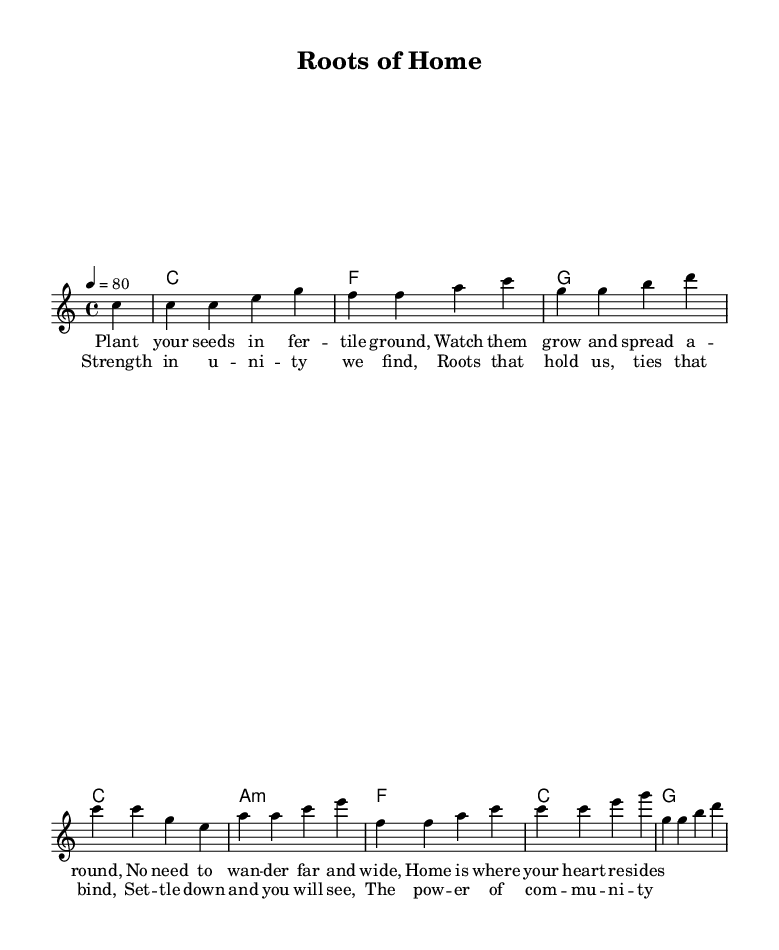What is the key signature of this music? The key signature is C major, which has no sharps or flats.
Answer: C major What is the time signature of this music piece? The time signature is indicated at the beginning of the piece, showing that it has four beats per measure.
Answer: 4/4 What is the tempo marking for this piece? The tempo marking indicates that the piece should be played at a speed of 80 beats per minute.
Answer: 80 How many measures are in the verse section? The verse section consists of four measures of music before the chorus begins, as indicated by the layout.
Answer: 4 What chord is sustained in the second measure of harmonies? The second measure contains an F major chord, as indicated by the chord names written above the music.
Answer: F What is the main theme expressed in the lyrics? The lyrics focus on the importance of community and settling down, which is reflected in lines about planting seeds and finding strength in unity.
Answer: Community strength What lyrical element is repeated in the chorus? The chorus prominently repeats the idea of unity and the power of community, emphasizing its significance and forming a thematic anchor for the piece.
Answer: Unity 